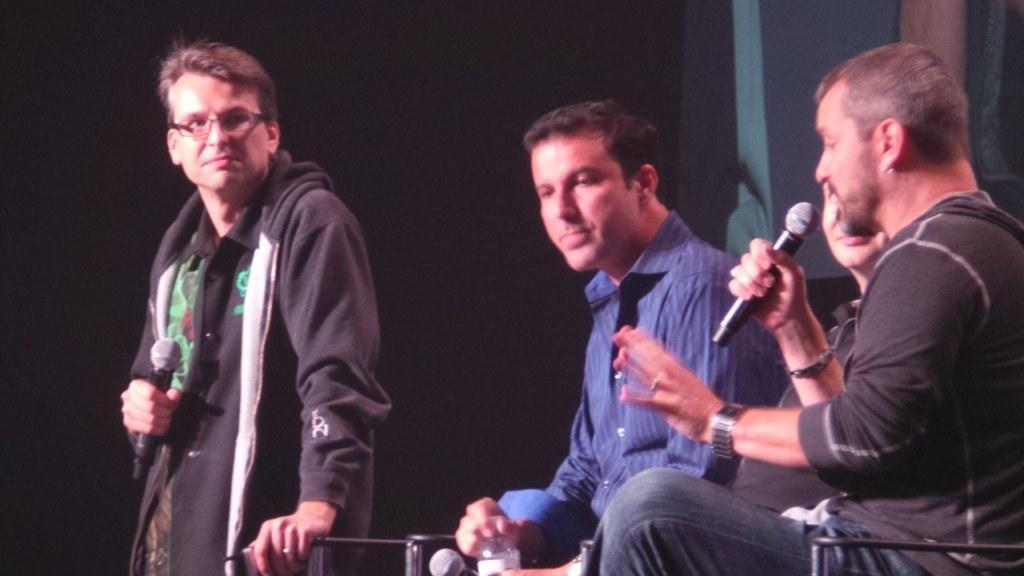In one or two sentences, can you explain what this image depicts? There are four people and three persons are sitting on a chair. On the right side we have a one person. He's holding a mic. The left side we have a another person is also holding a mic. 